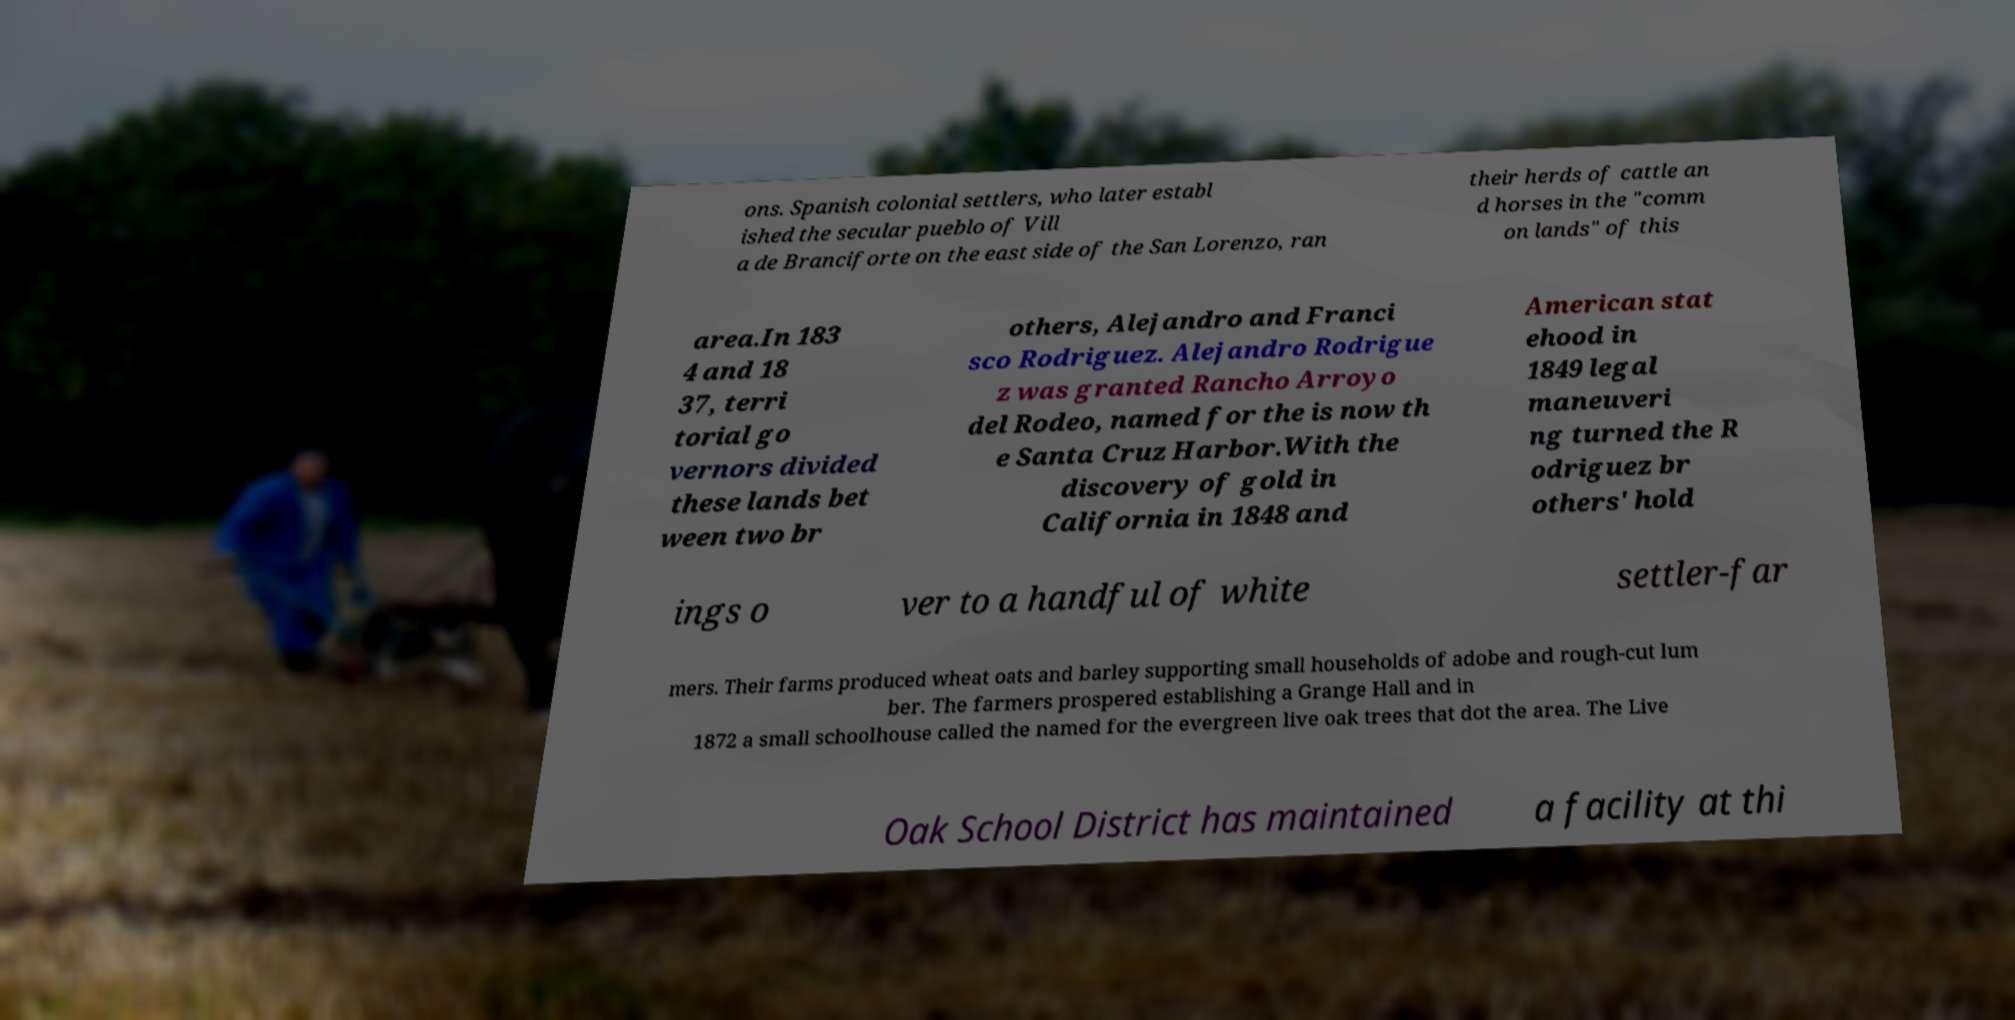Please identify and transcribe the text found in this image. ons. Spanish colonial settlers, who later establ ished the secular pueblo of Vill a de Branciforte on the east side of the San Lorenzo, ran their herds of cattle an d horses in the "comm on lands" of this area.In 183 4 and 18 37, terri torial go vernors divided these lands bet ween two br others, Alejandro and Franci sco Rodriguez. Alejandro Rodrigue z was granted Rancho Arroyo del Rodeo, named for the is now th e Santa Cruz Harbor.With the discovery of gold in California in 1848 and American stat ehood in 1849 legal maneuveri ng turned the R odriguez br others' hold ings o ver to a handful of white settler-far mers. Their farms produced wheat oats and barley supporting small households of adobe and rough-cut lum ber. The farmers prospered establishing a Grange Hall and in 1872 a small schoolhouse called the named for the evergreen live oak trees that dot the area. The Live Oak School District has maintained a facility at thi 